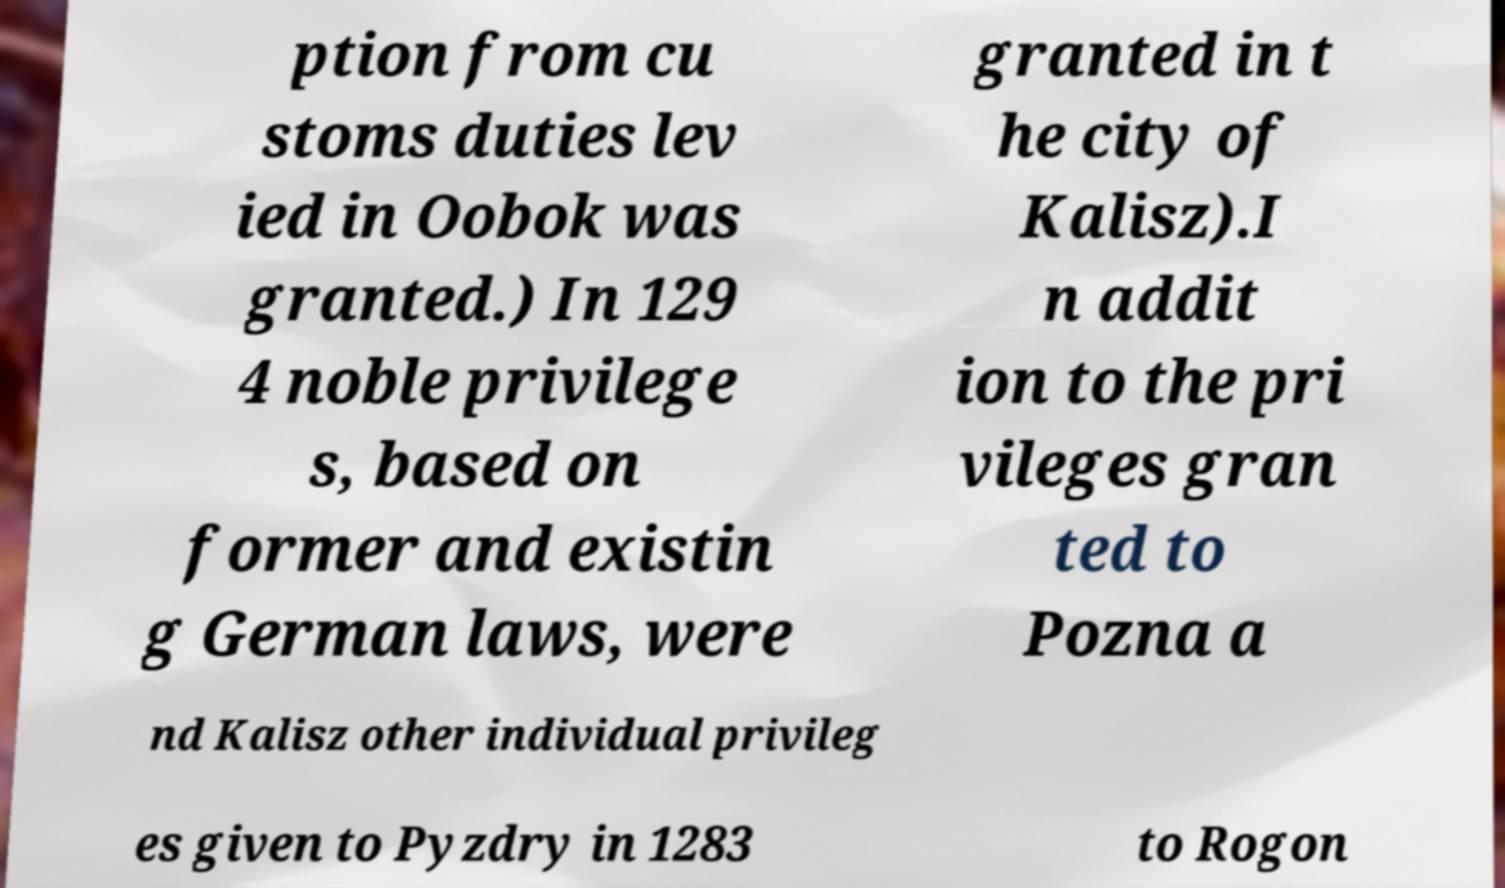Can you read and provide the text displayed in the image?This photo seems to have some interesting text. Can you extract and type it out for me? ption from cu stoms duties lev ied in Oobok was granted.) In 129 4 noble privilege s, based on former and existin g German laws, were granted in t he city of Kalisz).I n addit ion to the pri vileges gran ted to Pozna a nd Kalisz other individual privileg es given to Pyzdry in 1283 to Rogon 